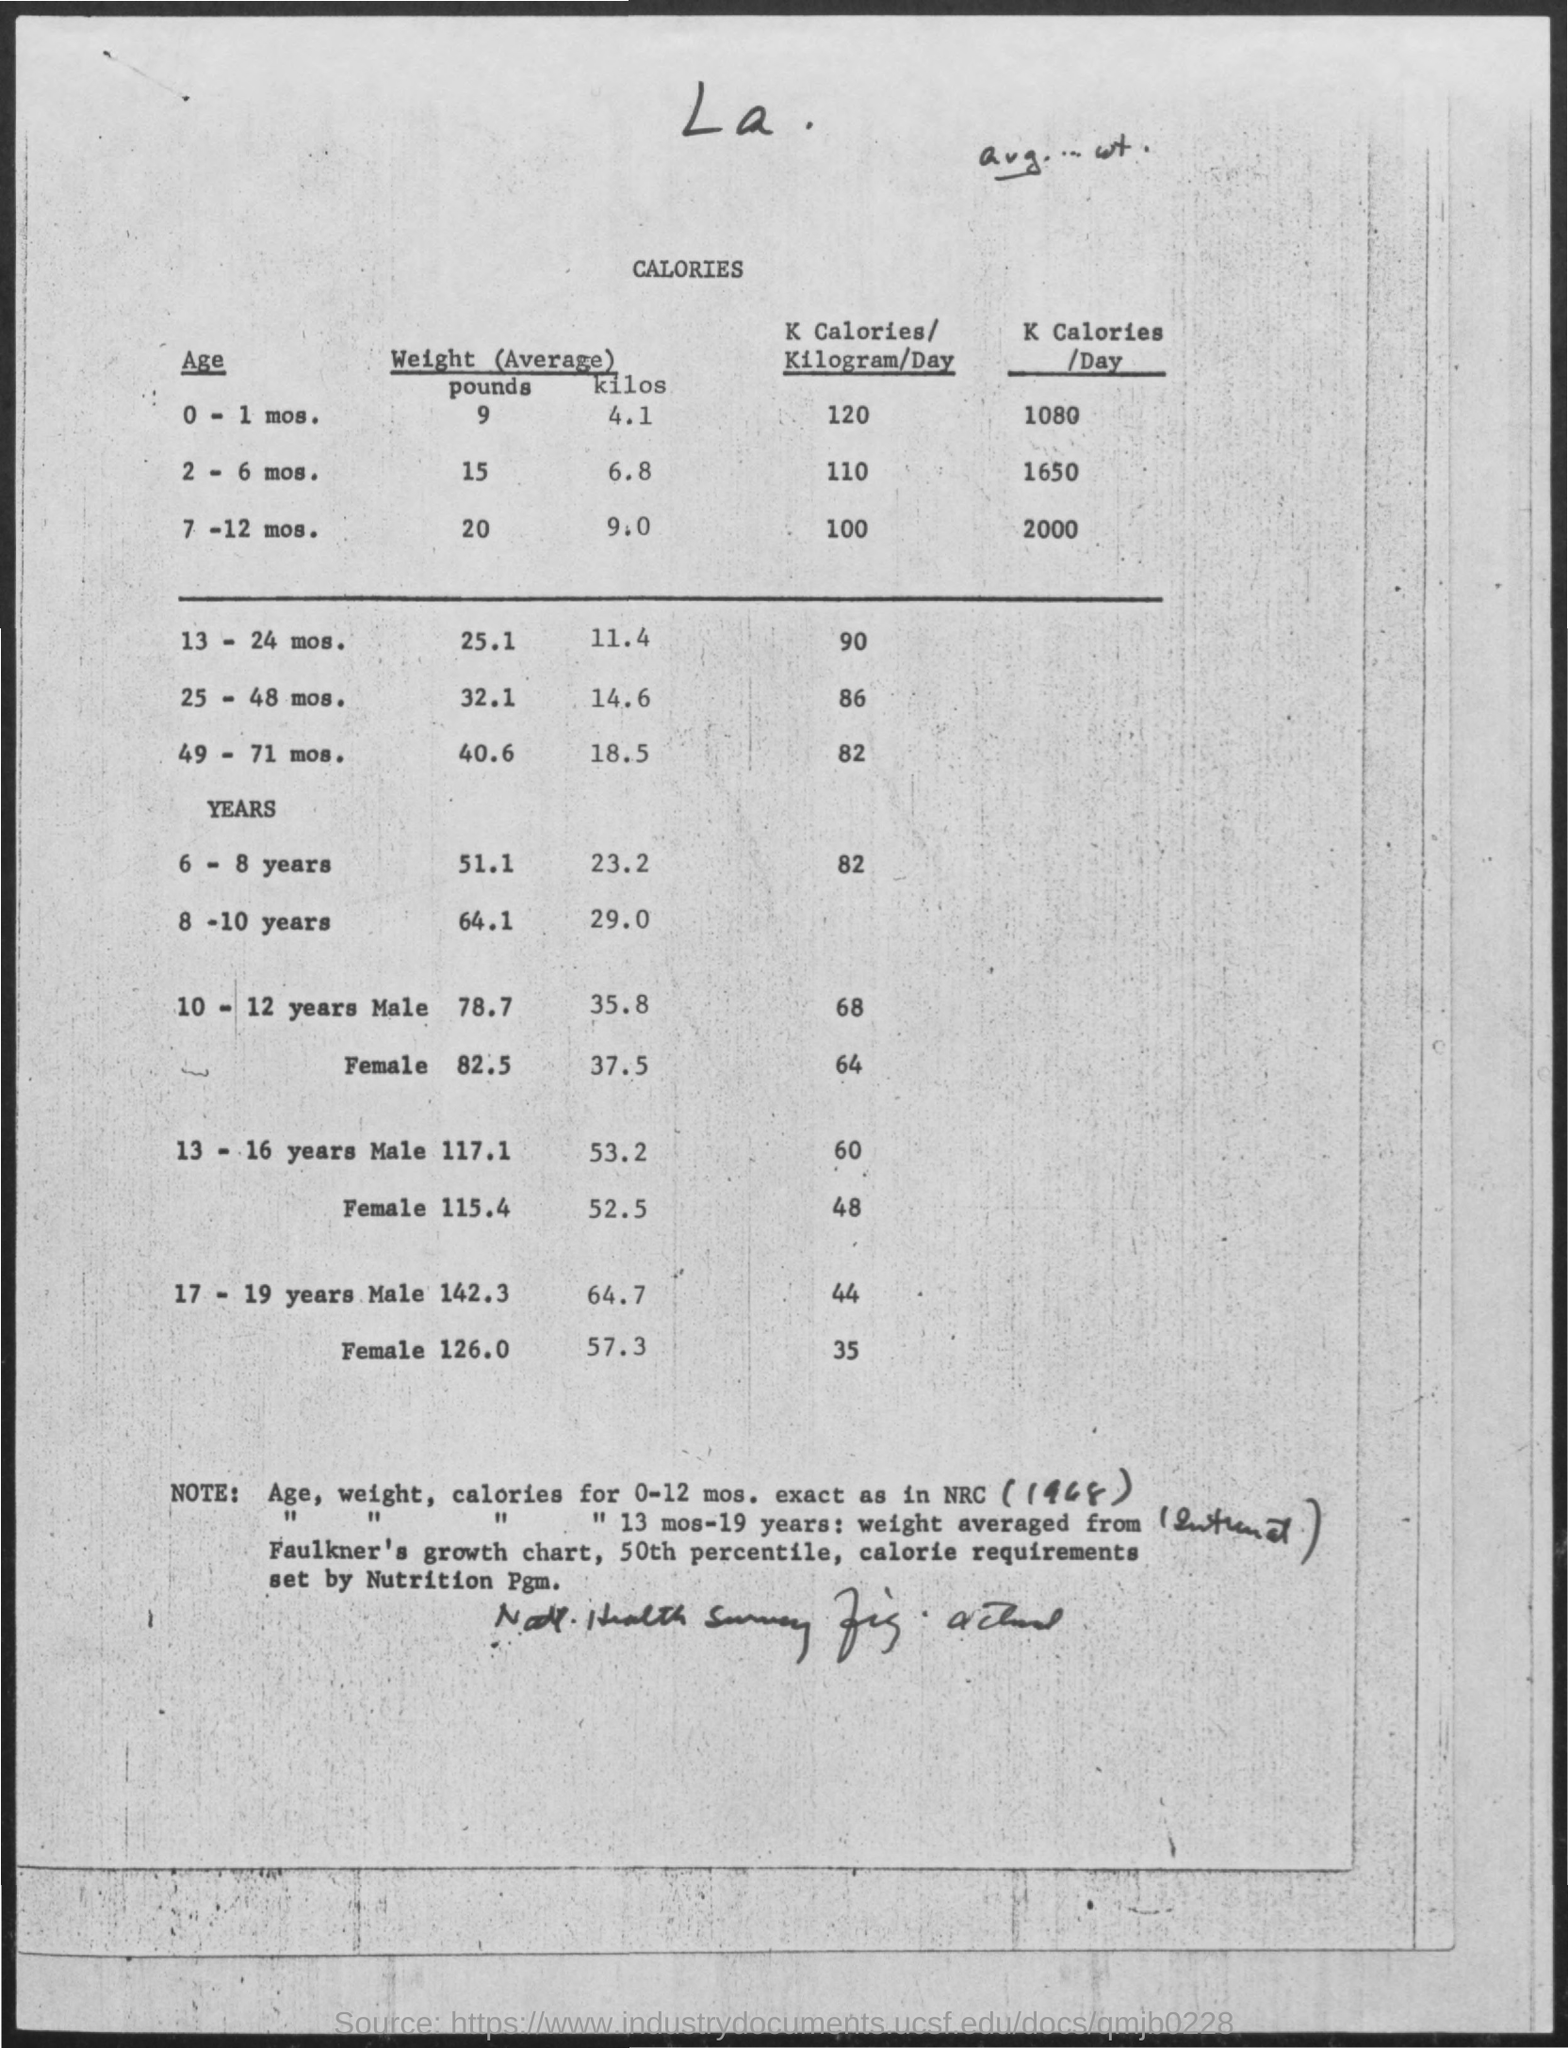Mention a couple of crucial points in this snapshot. The average weight for children between the ages of 6 and 8 is approximately 51.1 pounds. According to the given information, the average weight for 8-10 year olds is 64.1 pounds. The average weight for infants aged 7-12 months is approximately 20 pounds. The average weight for a 25-48-month-old child is approximately 14 kilos. The average weight for an infant aged 0-1 month is 9 pounds. 